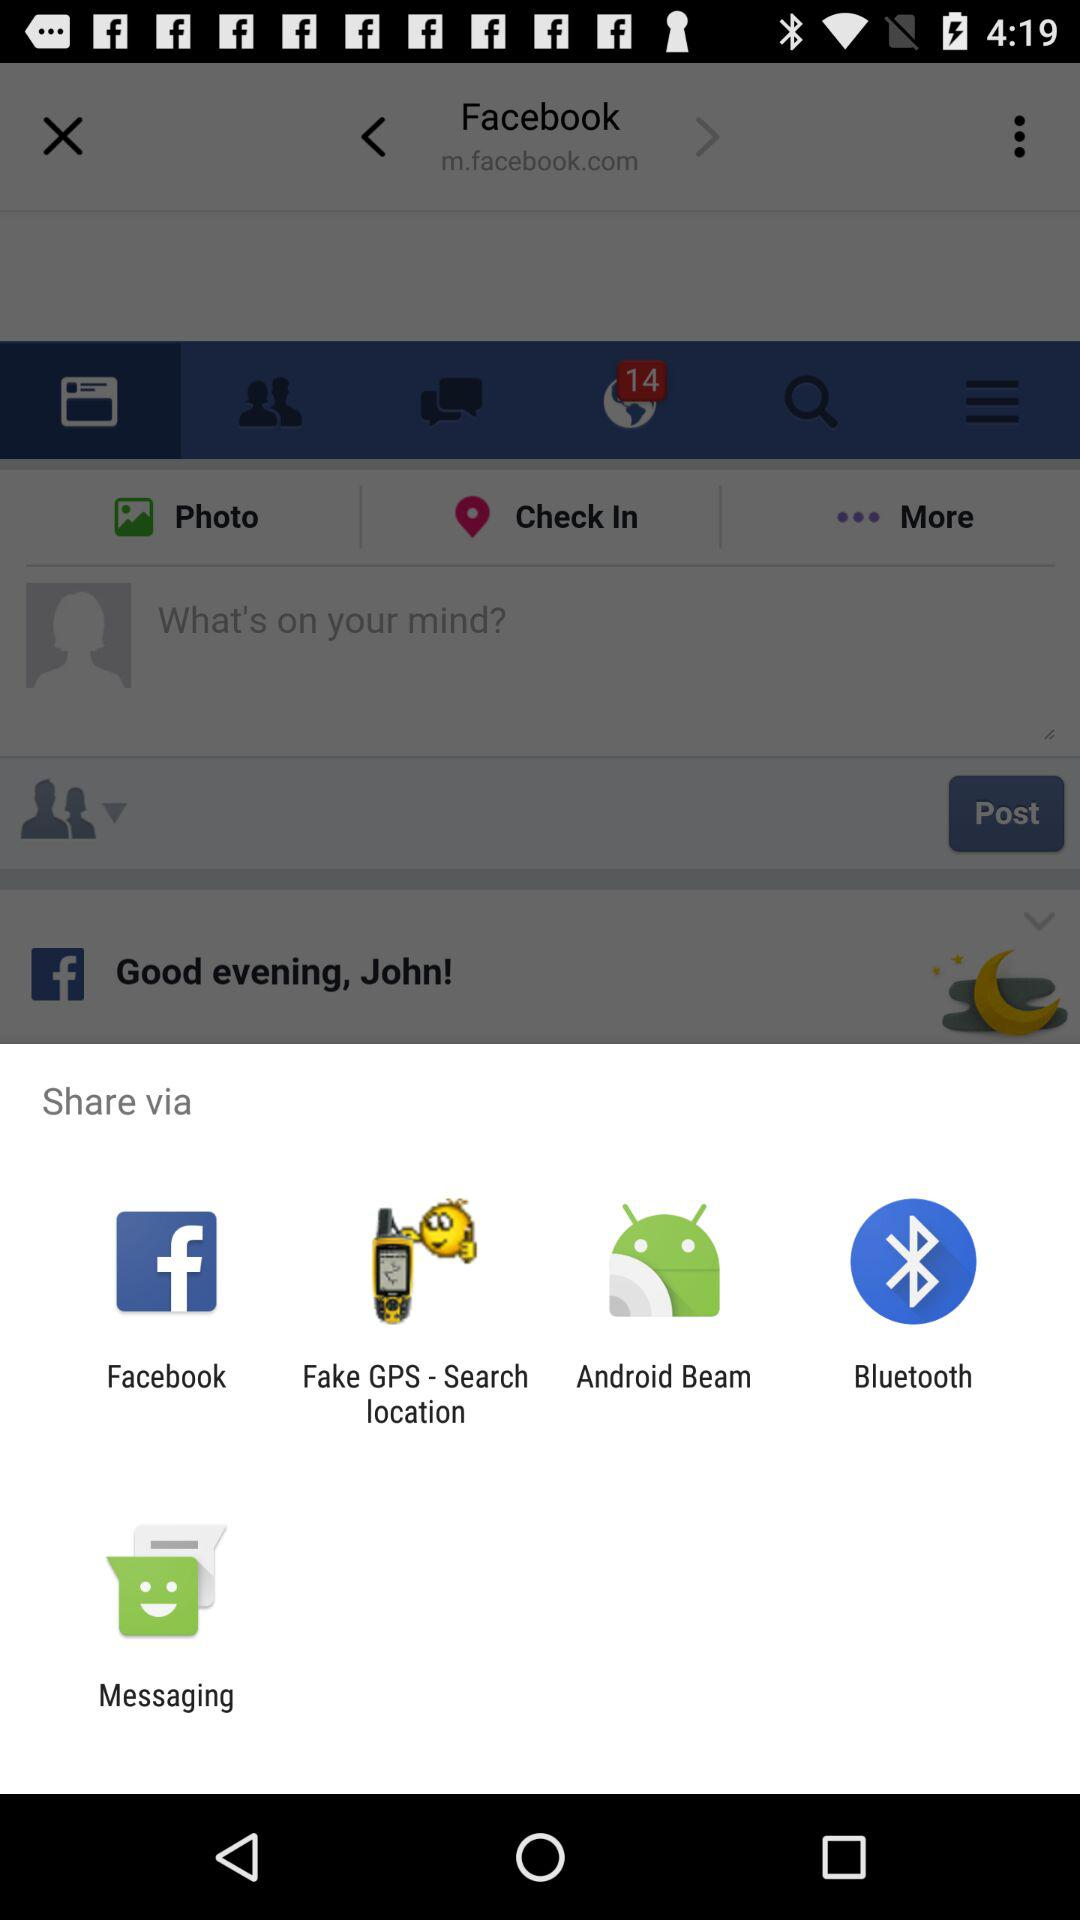Where did John check in?
When the provided information is insufficient, respond with <no answer>. <no answer> 